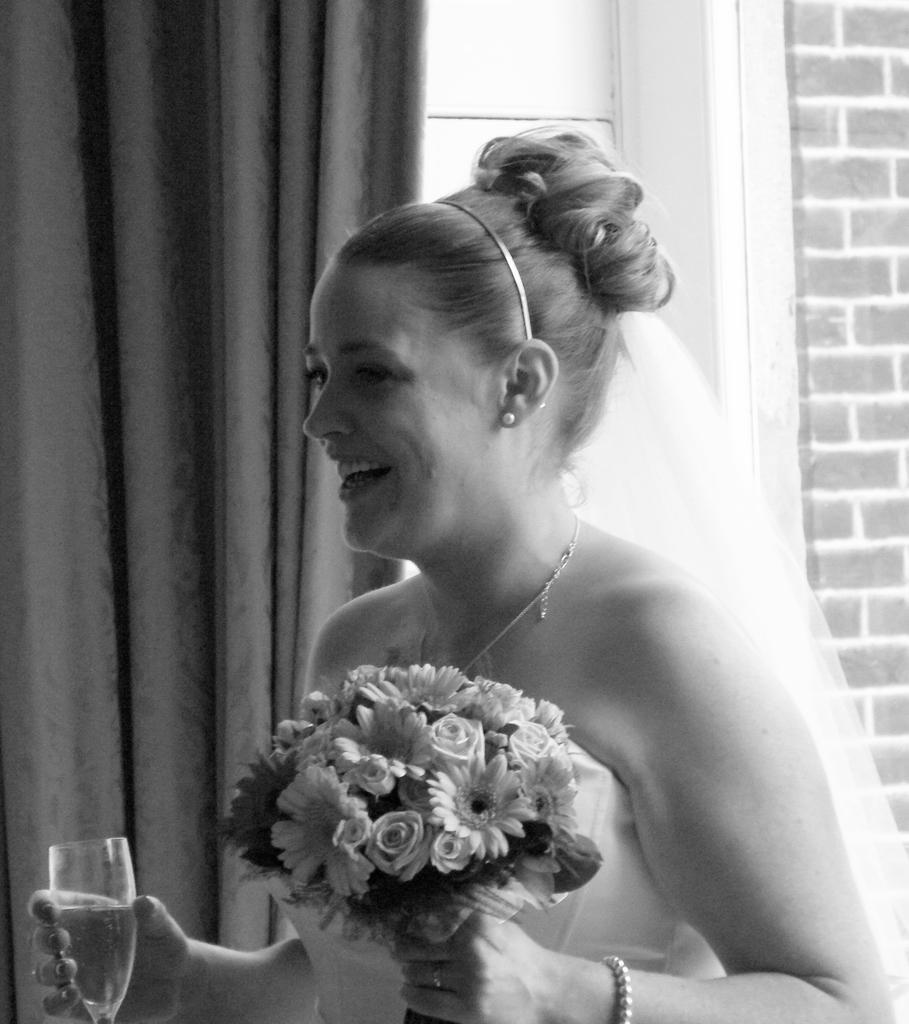Who is the main subject in the image? There is a woman in the image. Where is the woman positioned in the image? The woman is standing in the center. What is the woman holding in her left hand? The woman is holding a glass of wine in her left hand. What is the woman holding in her right hand? The woman is holding flowers in her right hand. What is the woman's facial expression in the image? The woman is smiling. What type of machine is the woman operating in the image? There is no machine present in the image; the woman is holding a glass of wine and flowers. What kind of oatmeal is the woman eating in the image? There is no oatmeal present in the image; the woman is holding a glass of wine and flowers. 